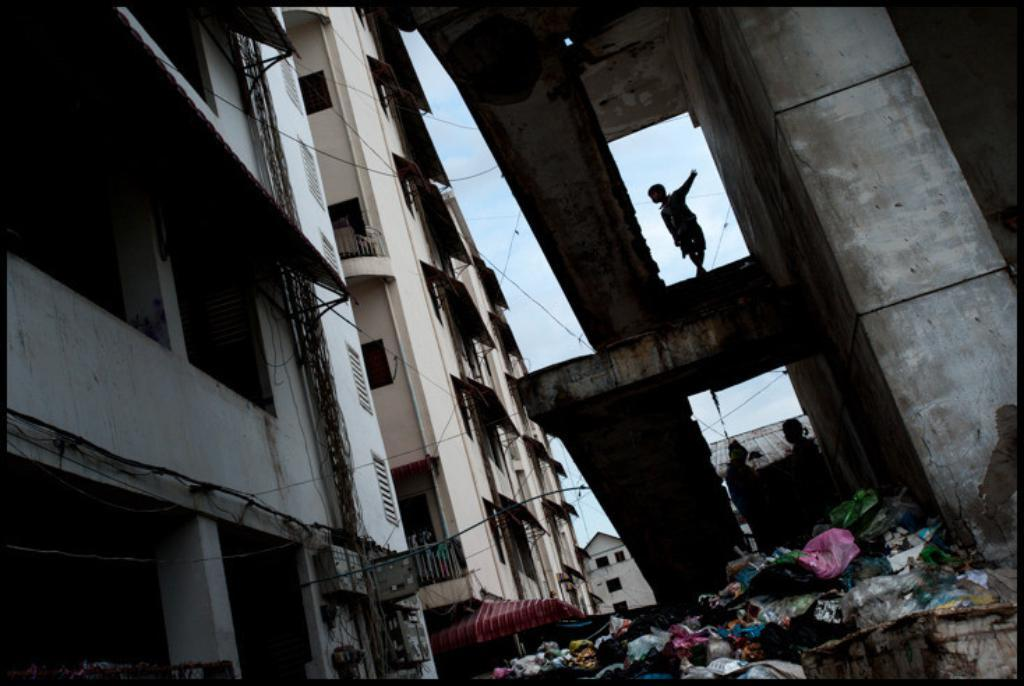What can be seen at the bottom of the image? There is dust at the bottom of the image. What is the main subject in the middle of the image? There is a kid on a staircase in the middle of the image. What type of structures are visible on the left side of the image? There are buildings on the left side of the image. How many chickens are present on the staircase in the image? There are no chickens present on the staircase in the image. What type of substance is the kid holding in the image? The provided facts do not mention any substance being held by the kid in the image. 